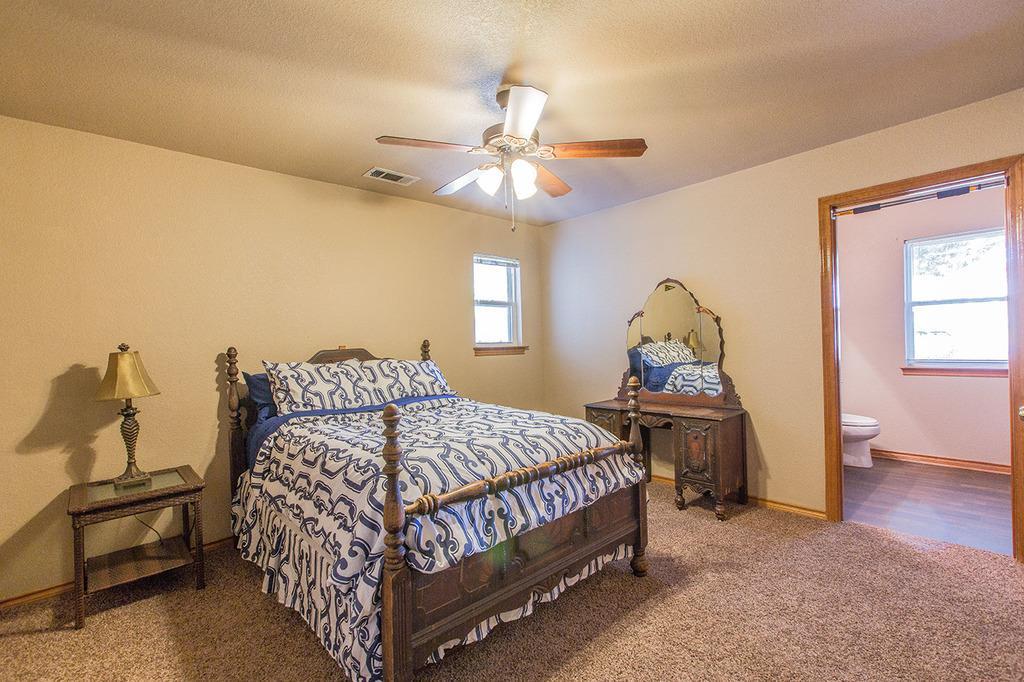Describe this image in one or two sentences. This image is taken indoors. At the top of the image there is a ceiling with a fan. In the background there are two walls with windows. At the bottom of the image there is a mat on the floor. In the middle of the image there is a bed with a bed sheet and pillows on it. There is a table with a lamp on it. There is a dressing table. On the right side of the image there is a toilet seat on the floor. 